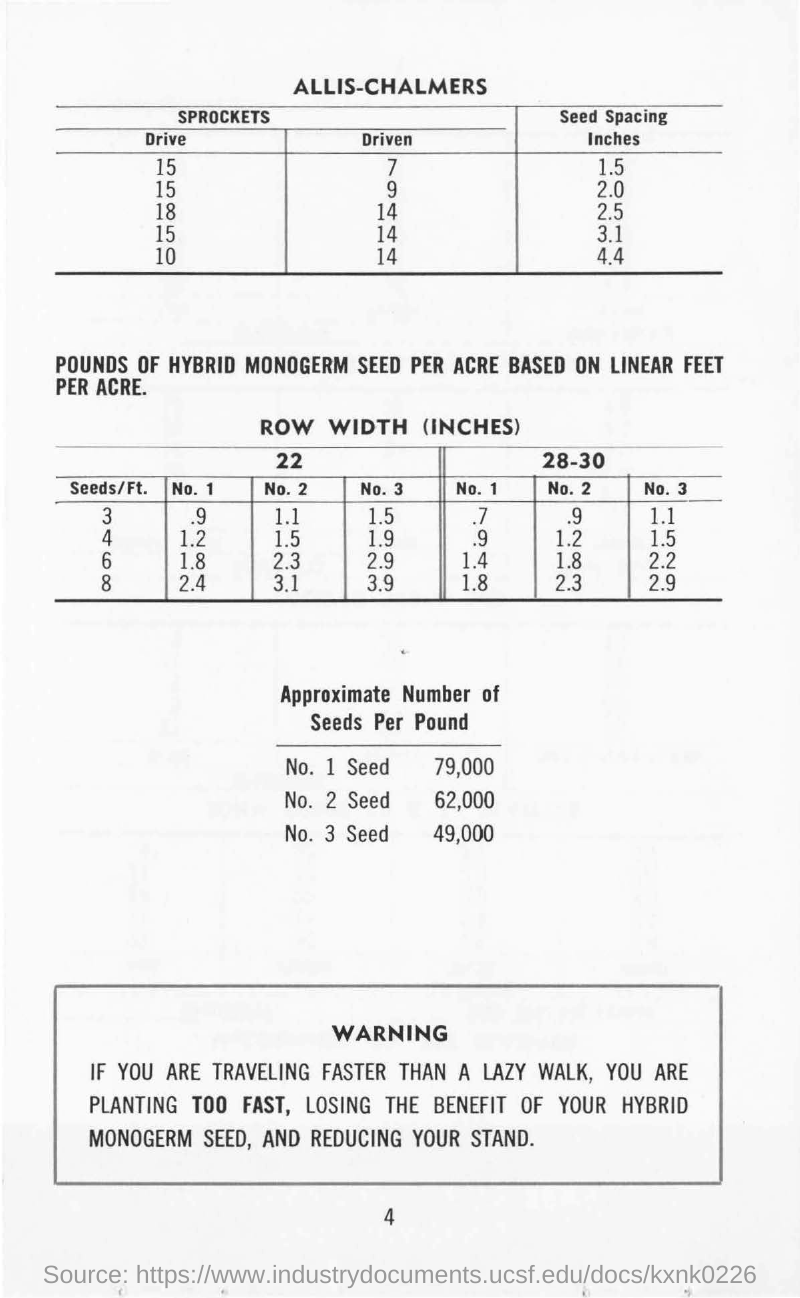Point out several critical features in this image. Approximately 30,000 seeds per pound can be expected in a 49,000 seed sample. Approximately 62,000 2-seed per pound. The heading of the first table is 'ALLIS-CHALMERS.' It is estimated that there are approximately 79,000 viable seed per pound of cannabis. The second heading of the table is "ROW WIDTH (INCHES).. 